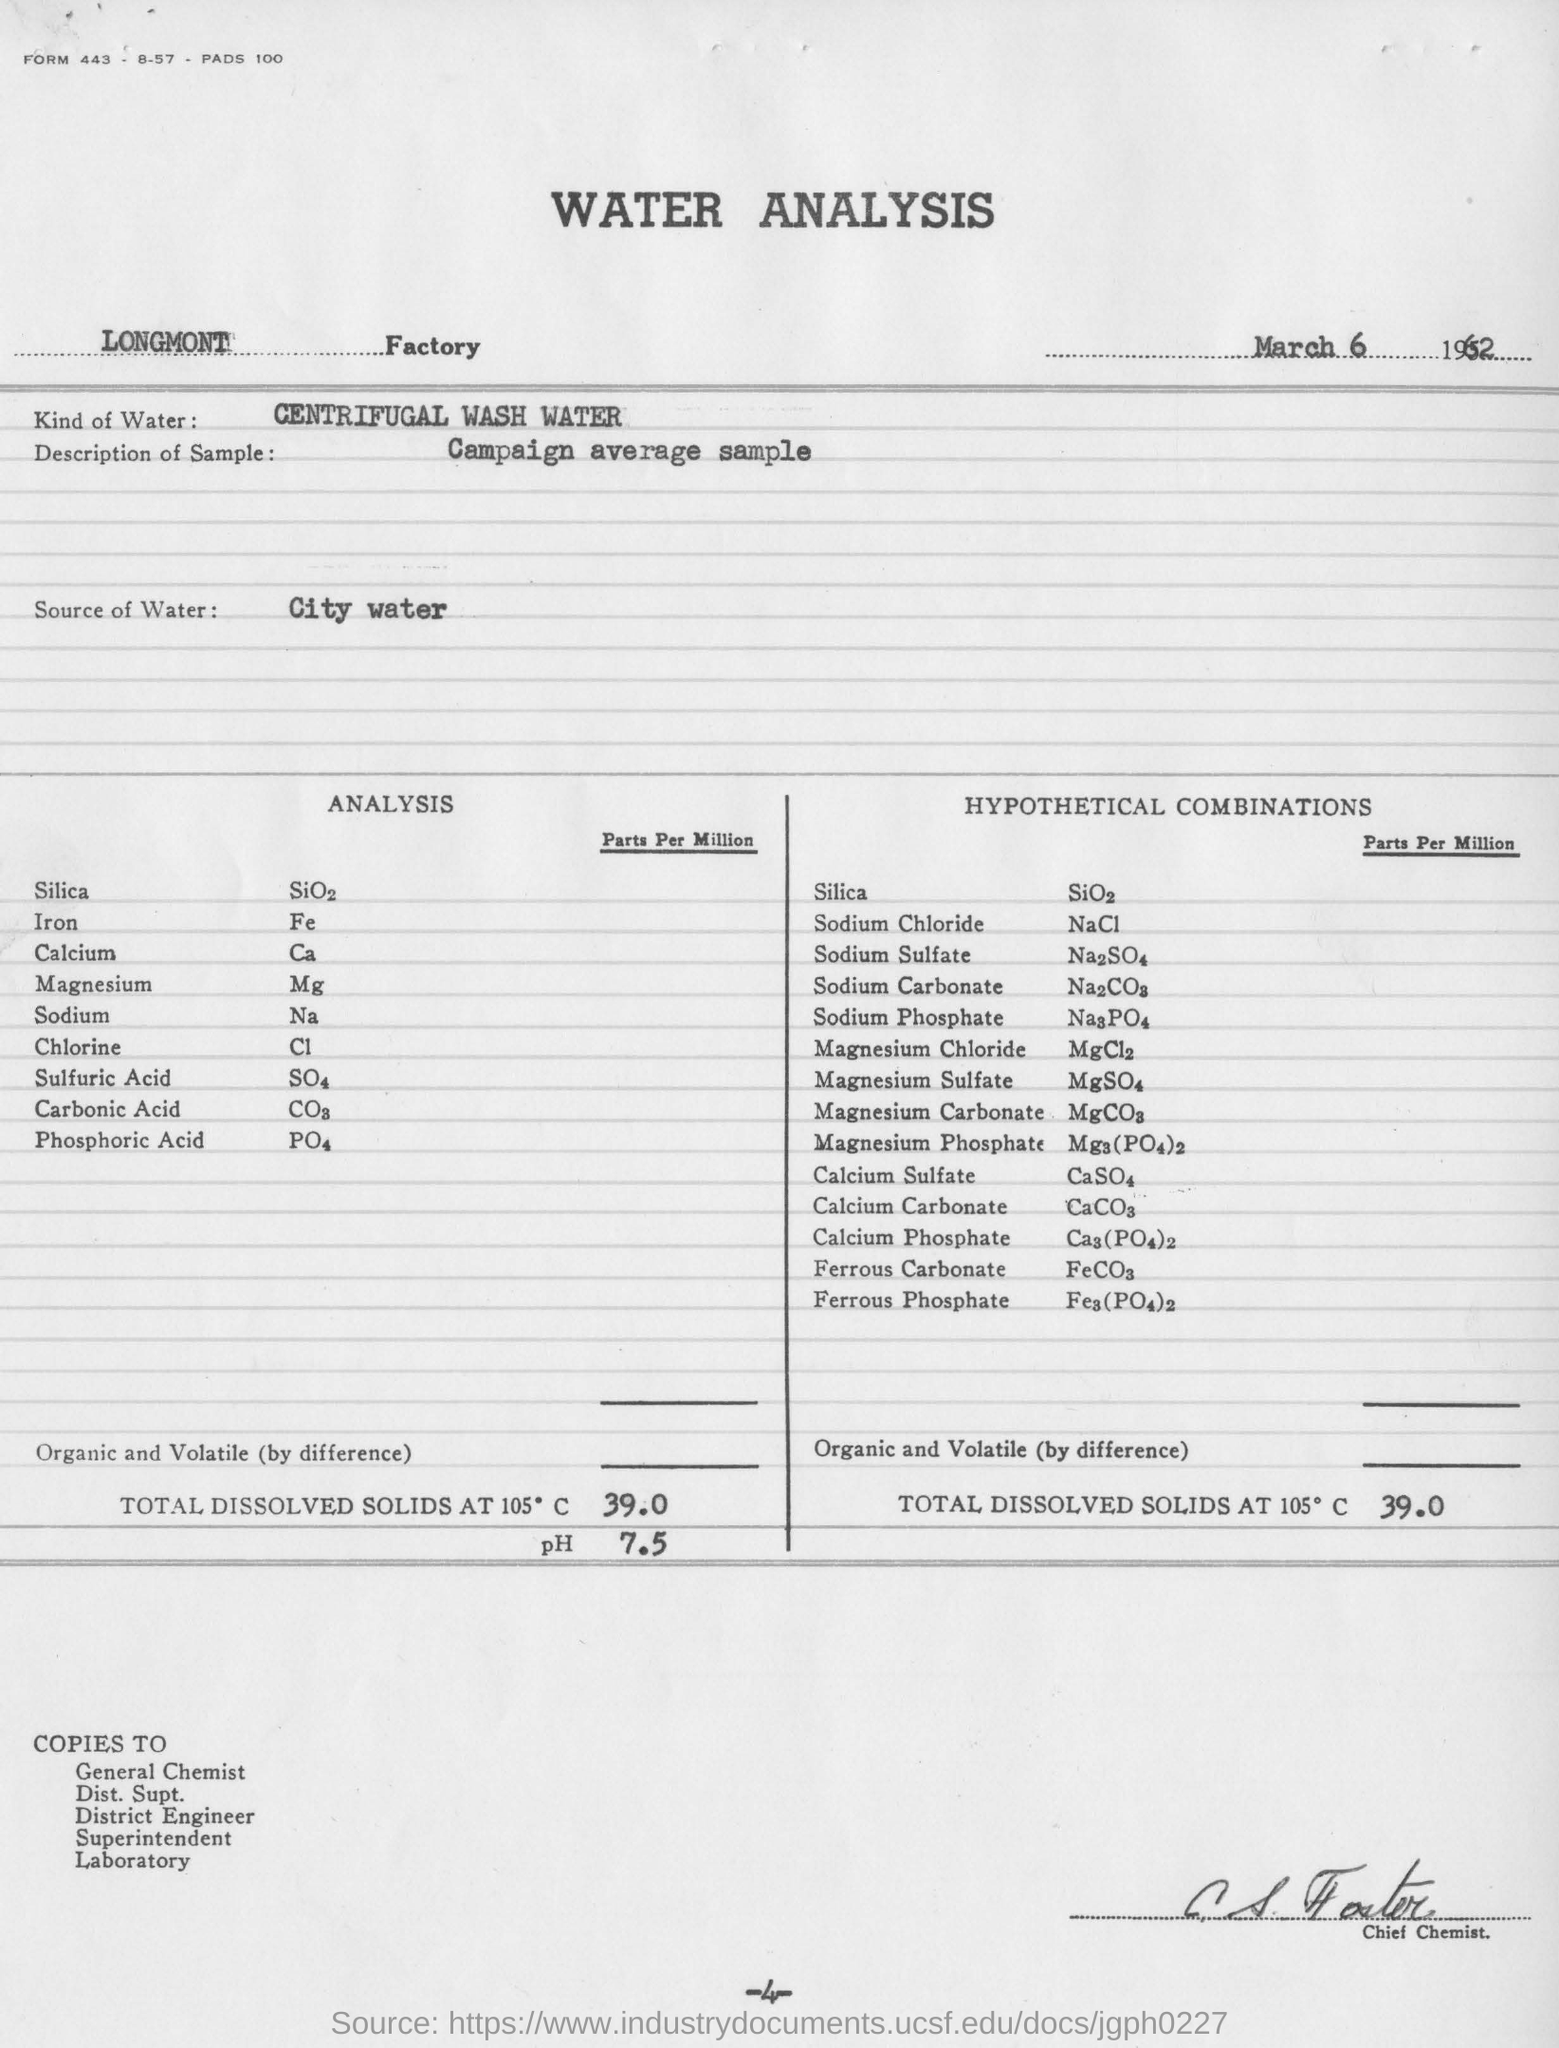What is the title of the document ?
Your response must be concise. Water analysis. What is the factory name ?
Ensure brevity in your answer.  Longmont. What is the date mentioned in the top of the document ?
Offer a very short reply. March 6 1962. What kind of water ?
Give a very brief answer. Centrifugal wash water. What is the Sample Description ?
Ensure brevity in your answer.  Campaign average sample. What is the formula for Iron ?
Your answer should be very brief. Fe. What is the formula for Chlorine ?
Your answer should be compact. Cl. What is the formula for Sodium?
Your response must be concise. Na. What is the chemical formula for Calcium ?
Provide a succinct answer. Ca. 